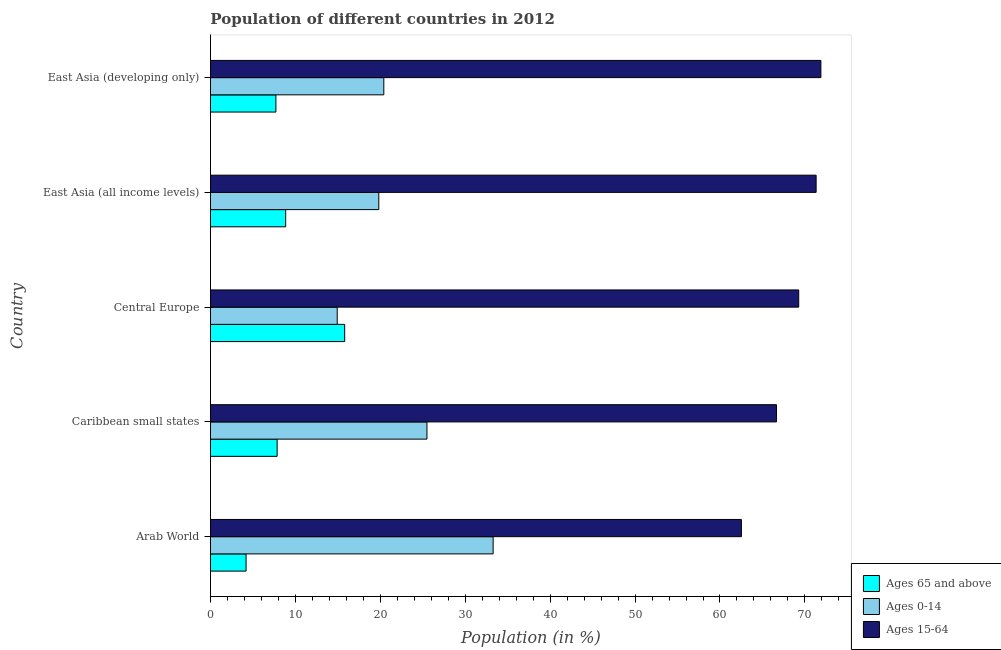How many different coloured bars are there?
Your response must be concise. 3. How many groups of bars are there?
Keep it short and to the point. 5. Are the number of bars per tick equal to the number of legend labels?
Provide a succinct answer. Yes. What is the label of the 2nd group of bars from the top?
Your answer should be compact. East Asia (all income levels). In how many cases, is the number of bars for a given country not equal to the number of legend labels?
Provide a succinct answer. 0. What is the percentage of population within the age-group 15-64 in Arab World?
Offer a terse response. 62.52. Across all countries, what is the maximum percentage of population within the age-group of 65 and above?
Your answer should be compact. 15.8. Across all countries, what is the minimum percentage of population within the age-group 15-64?
Your response must be concise. 62.52. In which country was the percentage of population within the age-group of 65 and above maximum?
Give a very brief answer. Central Europe. In which country was the percentage of population within the age-group 0-14 minimum?
Keep it short and to the point. Central Europe. What is the total percentage of population within the age-group 0-14 in the graph?
Your answer should be very brief. 113.94. What is the difference between the percentage of population within the age-group 0-14 in Arab World and that in East Asia (all income levels)?
Keep it short and to the point. 13.46. What is the difference between the percentage of population within the age-group of 65 and above in Caribbean small states and the percentage of population within the age-group 0-14 in East Asia (developing only)?
Make the answer very short. -12.56. What is the average percentage of population within the age-group of 65 and above per country?
Make the answer very short. 8.88. What is the difference between the percentage of population within the age-group 0-14 and percentage of population within the age-group 15-64 in Caribbean small states?
Your response must be concise. -41.16. In how many countries, is the percentage of population within the age-group 0-14 greater than 24 %?
Provide a succinct answer. 2. What is the ratio of the percentage of population within the age-group of 65 and above in Arab World to that in East Asia (developing only)?
Your answer should be very brief. 0.54. What is the difference between the highest and the second highest percentage of population within the age-group of 65 and above?
Provide a succinct answer. 6.95. What is the difference between the highest and the lowest percentage of population within the age-group 0-14?
Your answer should be compact. 18.36. Is the sum of the percentage of population within the age-group 0-14 in East Asia (all income levels) and East Asia (developing only) greater than the maximum percentage of population within the age-group 15-64 across all countries?
Provide a short and direct response. No. What does the 3rd bar from the top in Arab World represents?
Provide a succinct answer. Ages 65 and above. What does the 2nd bar from the bottom in Central Europe represents?
Provide a succinct answer. Ages 0-14. Is it the case that in every country, the sum of the percentage of population within the age-group of 65 and above and percentage of population within the age-group 0-14 is greater than the percentage of population within the age-group 15-64?
Offer a terse response. No. How many bars are there?
Make the answer very short. 15. Are all the bars in the graph horizontal?
Provide a short and direct response. Yes. Are the values on the major ticks of X-axis written in scientific E-notation?
Make the answer very short. No. Where does the legend appear in the graph?
Your answer should be very brief. Bottom right. What is the title of the graph?
Your answer should be compact. Population of different countries in 2012. What is the Population (in %) of Ages 65 and above in Arab World?
Provide a short and direct response. 4.19. What is the Population (in %) of Ages 0-14 in Arab World?
Your answer should be very brief. 33.29. What is the Population (in %) of Ages 15-64 in Arab World?
Make the answer very short. 62.52. What is the Population (in %) in Ages 65 and above in Caribbean small states?
Provide a succinct answer. 7.85. What is the Population (in %) in Ages 0-14 in Caribbean small states?
Give a very brief answer. 25.49. What is the Population (in %) of Ages 15-64 in Caribbean small states?
Make the answer very short. 66.66. What is the Population (in %) of Ages 65 and above in Central Europe?
Give a very brief answer. 15.8. What is the Population (in %) in Ages 0-14 in Central Europe?
Your answer should be very brief. 14.93. What is the Population (in %) of Ages 15-64 in Central Europe?
Keep it short and to the point. 69.27. What is the Population (in %) of Ages 65 and above in East Asia (all income levels)?
Provide a succinct answer. 8.86. What is the Population (in %) in Ages 0-14 in East Asia (all income levels)?
Ensure brevity in your answer.  19.82. What is the Population (in %) in Ages 15-64 in East Asia (all income levels)?
Make the answer very short. 71.32. What is the Population (in %) of Ages 65 and above in East Asia (developing only)?
Provide a succinct answer. 7.7. What is the Population (in %) in Ages 0-14 in East Asia (developing only)?
Your response must be concise. 20.41. What is the Population (in %) in Ages 15-64 in East Asia (developing only)?
Your response must be concise. 71.88. Across all countries, what is the maximum Population (in %) in Ages 65 and above?
Your answer should be very brief. 15.8. Across all countries, what is the maximum Population (in %) in Ages 0-14?
Ensure brevity in your answer.  33.29. Across all countries, what is the maximum Population (in %) in Ages 15-64?
Provide a short and direct response. 71.88. Across all countries, what is the minimum Population (in %) in Ages 65 and above?
Provide a succinct answer. 4.19. Across all countries, what is the minimum Population (in %) of Ages 0-14?
Offer a very short reply. 14.93. Across all countries, what is the minimum Population (in %) of Ages 15-64?
Ensure brevity in your answer.  62.52. What is the total Population (in %) of Ages 65 and above in the graph?
Offer a very short reply. 44.41. What is the total Population (in %) of Ages 0-14 in the graph?
Provide a short and direct response. 113.94. What is the total Population (in %) of Ages 15-64 in the graph?
Give a very brief answer. 341.65. What is the difference between the Population (in %) in Ages 65 and above in Arab World and that in Caribbean small states?
Offer a very short reply. -3.66. What is the difference between the Population (in %) in Ages 0-14 in Arab World and that in Caribbean small states?
Your response must be concise. 7.79. What is the difference between the Population (in %) in Ages 15-64 in Arab World and that in Caribbean small states?
Offer a terse response. -4.14. What is the difference between the Population (in %) in Ages 65 and above in Arab World and that in Central Europe?
Provide a short and direct response. -11.61. What is the difference between the Population (in %) in Ages 0-14 in Arab World and that in Central Europe?
Your answer should be compact. 18.36. What is the difference between the Population (in %) of Ages 15-64 in Arab World and that in Central Europe?
Give a very brief answer. -6.75. What is the difference between the Population (in %) in Ages 65 and above in Arab World and that in East Asia (all income levels)?
Provide a succinct answer. -4.66. What is the difference between the Population (in %) in Ages 0-14 in Arab World and that in East Asia (all income levels)?
Give a very brief answer. 13.46. What is the difference between the Population (in %) in Ages 15-64 in Arab World and that in East Asia (all income levels)?
Your response must be concise. -8.8. What is the difference between the Population (in %) in Ages 65 and above in Arab World and that in East Asia (developing only)?
Give a very brief answer. -3.51. What is the difference between the Population (in %) in Ages 0-14 in Arab World and that in East Asia (developing only)?
Your answer should be compact. 12.87. What is the difference between the Population (in %) of Ages 15-64 in Arab World and that in East Asia (developing only)?
Provide a succinct answer. -9.36. What is the difference between the Population (in %) in Ages 65 and above in Caribbean small states and that in Central Europe?
Your answer should be compact. -7.95. What is the difference between the Population (in %) of Ages 0-14 in Caribbean small states and that in Central Europe?
Give a very brief answer. 10.57. What is the difference between the Population (in %) in Ages 15-64 in Caribbean small states and that in Central Europe?
Ensure brevity in your answer.  -2.61. What is the difference between the Population (in %) in Ages 65 and above in Caribbean small states and that in East Asia (all income levels)?
Keep it short and to the point. -1.01. What is the difference between the Population (in %) of Ages 0-14 in Caribbean small states and that in East Asia (all income levels)?
Your response must be concise. 5.67. What is the difference between the Population (in %) of Ages 15-64 in Caribbean small states and that in East Asia (all income levels)?
Offer a very short reply. -4.67. What is the difference between the Population (in %) of Ages 65 and above in Caribbean small states and that in East Asia (developing only)?
Offer a very short reply. 0.15. What is the difference between the Population (in %) in Ages 0-14 in Caribbean small states and that in East Asia (developing only)?
Give a very brief answer. 5.08. What is the difference between the Population (in %) of Ages 15-64 in Caribbean small states and that in East Asia (developing only)?
Offer a terse response. -5.23. What is the difference between the Population (in %) in Ages 65 and above in Central Europe and that in East Asia (all income levels)?
Your answer should be very brief. 6.95. What is the difference between the Population (in %) of Ages 0-14 in Central Europe and that in East Asia (all income levels)?
Your answer should be very brief. -4.9. What is the difference between the Population (in %) in Ages 15-64 in Central Europe and that in East Asia (all income levels)?
Provide a succinct answer. -2.05. What is the difference between the Population (in %) in Ages 65 and above in Central Europe and that in East Asia (developing only)?
Provide a succinct answer. 8.1. What is the difference between the Population (in %) in Ages 0-14 in Central Europe and that in East Asia (developing only)?
Offer a very short reply. -5.49. What is the difference between the Population (in %) of Ages 15-64 in Central Europe and that in East Asia (developing only)?
Offer a terse response. -2.61. What is the difference between the Population (in %) of Ages 65 and above in East Asia (all income levels) and that in East Asia (developing only)?
Provide a succinct answer. 1.15. What is the difference between the Population (in %) of Ages 0-14 in East Asia (all income levels) and that in East Asia (developing only)?
Give a very brief answer. -0.59. What is the difference between the Population (in %) of Ages 15-64 in East Asia (all income levels) and that in East Asia (developing only)?
Give a very brief answer. -0.56. What is the difference between the Population (in %) of Ages 65 and above in Arab World and the Population (in %) of Ages 0-14 in Caribbean small states?
Offer a very short reply. -21.3. What is the difference between the Population (in %) of Ages 65 and above in Arab World and the Population (in %) of Ages 15-64 in Caribbean small states?
Ensure brevity in your answer.  -62.46. What is the difference between the Population (in %) in Ages 0-14 in Arab World and the Population (in %) in Ages 15-64 in Caribbean small states?
Provide a short and direct response. -33.37. What is the difference between the Population (in %) in Ages 65 and above in Arab World and the Population (in %) in Ages 0-14 in Central Europe?
Give a very brief answer. -10.73. What is the difference between the Population (in %) of Ages 65 and above in Arab World and the Population (in %) of Ages 15-64 in Central Europe?
Offer a very short reply. -65.08. What is the difference between the Population (in %) of Ages 0-14 in Arab World and the Population (in %) of Ages 15-64 in Central Europe?
Give a very brief answer. -35.98. What is the difference between the Population (in %) in Ages 65 and above in Arab World and the Population (in %) in Ages 0-14 in East Asia (all income levels)?
Provide a short and direct response. -15.63. What is the difference between the Population (in %) of Ages 65 and above in Arab World and the Population (in %) of Ages 15-64 in East Asia (all income levels)?
Offer a terse response. -67.13. What is the difference between the Population (in %) in Ages 0-14 in Arab World and the Population (in %) in Ages 15-64 in East Asia (all income levels)?
Provide a succinct answer. -38.04. What is the difference between the Population (in %) in Ages 65 and above in Arab World and the Population (in %) in Ages 0-14 in East Asia (developing only)?
Your answer should be very brief. -16.22. What is the difference between the Population (in %) in Ages 65 and above in Arab World and the Population (in %) in Ages 15-64 in East Asia (developing only)?
Your answer should be very brief. -67.69. What is the difference between the Population (in %) in Ages 0-14 in Arab World and the Population (in %) in Ages 15-64 in East Asia (developing only)?
Give a very brief answer. -38.6. What is the difference between the Population (in %) of Ages 65 and above in Caribbean small states and the Population (in %) of Ages 0-14 in Central Europe?
Offer a very short reply. -7.08. What is the difference between the Population (in %) in Ages 65 and above in Caribbean small states and the Population (in %) in Ages 15-64 in Central Europe?
Provide a short and direct response. -61.42. What is the difference between the Population (in %) of Ages 0-14 in Caribbean small states and the Population (in %) of Ages 15-64 in Central Europe?
Provide a short and direct response. -43.78. What is the difference between the Population (in %) of Ages 65 and above in Caribbean small states and the Population (in %) of Ages 0-14 in East Asia (all income levels)?
Your answer should be compact. -11.97. What is the difference between the Population (in %) in Ages 65 and above in Caribbean small states and the Population (in %) in Ages 15-64 in East Asia (all income levels)?
Provide a succinct answer. -63.47. What is the difference between the Population (in %) in Ages 0-14 in Caribbean small states and the Population (in %) in Ages 15-64 in East Asia (all income levels)?
Offer a terse response. -45.83. What is the difference between the Population (in %) of Ages 65 and above in Caribbean small states and the Population (in %) of Ages 0-14 in East Asia (developing only)?
Your answer should be compact. -12.56. What is the difference between the Population (in %) in Ages 65 and above in Caribbean small states and the Population (in %) in Ages 15-64 in East Asia (developing only)?
Your answer should be very brief. -64.03. What is the difference between the Population (in %) of Ages 0-14 in Caribbean small states and the Population (in %) of Ages 15-64 in East Asia (developing only)?
Make the answer very short. -46.39. What is the difference between the Population (in %) in Ages 65 and above in Central Europe and the Population (in %) in Ages 0-14 in East Asia (all income levels)?
Make the answer very short. -4.02. What is the difference between the Population (in %) in Ages 65 and above in Central Europe and the Population (in %) in Ages 15-64 in East Asia (all income levels)?
Keep it short and to the point. -55.52. What is the difference between the Population (in %) of Ages 0-14 in Central Europe and the Population (in %) of Ages 15-64 in East Asia (all income levels)?
Your answer should be very brief. -56.4. What is the difference between the Population (in %) of Ages 65 and above in Central Europe and the Population (in %) of Ages 0-14 in East Asia (developing only)?
Offer a terse response. -4.61. What is the difference between the Population (in %) of Ages 65 and above in Central Europe and the Population (in %) of Ages 15-64 in East Asia (developing only)?
Offer a very short reply. -56.08. What is the difference between the Population (in %) in Ages 0-14 in Central Europe and the Population (in %) in Ages 15-64 in East Asia (developing only)?
Offer a very short reply. -56.96. What is the difference between the Population (in %) in Ages 65 and above in East Asia (all income levels) and the Population (in %) in Ages 0-14 in East Asia (developing only)?
Your response must be concise. -11.56. What is the difference between the Population (in %) in Ages 65 and above in East Asia (all income levels) and the Population (in %) in Ages 15-64 in East Asia (developing only)?
Keep it short and to the point. -63.03. What is the difference between the Population (in %) of Ages 0-14 in East Asia (all income levels) and the Population (in %) of Ages 15-64 in East Asia (developing only)?
Offer a terse response. -52.06. What is the average Population (in %) of Ages 65 and above per country?
Your answer should be very brief. 8.88. What is the average Population (in %) of Ages 0-14 per country?
Keep it short and to the point. 22.79. What is the average Population (in %) of Ages 15-64 per country?
Your answer should be very brief. 68.33. What is the difference between the Population (in %) of Ages 65 and above and Population (in %) of Ages 0-14 in Arab World?
Keep it short and to the point. -29.09. What is the difference between the Population (in %) of Ages 65 and above and Population (in %) of Ages 15-64 in Arab World?
Make the answer very short. -58.33. What is the difference between the Population (in %) of Ages 0-14 and Population (in %) of Ages 15-64 in Arab World?
Your answer should be very brief. -29.23. What is the difference between the Population (in %) of Ages 65 and above and Population (in %) of Ages 0-14 in Caribbean small states?
Your response must be concise. -17.64. What is the difference between the Population (in %) of Ages 65 and above and Population (in %) of Ages 15-64 in Caribbean small states?
Your answer should be very brief. -58.81. What is the difference between the Population (in %) in Ages 0-14 and Population (in %) in Ages 15-64 in Caribbean small states?
Give a very brief answer. -41.16. What is the difference between the Population (in %) of Ages 65 and above and Population (in %) of Ages 0-14 in Central Europe?
Give a very brief answer. 0.88. What is the difference between the Population (in %) in Ages 65 and above and Population (in %) in Ages 15-64 in Central Europe?
Make the answer very short. -53.47. What is the difference between the Population (in %) of Ages 0-14 and Population (in %) of Ages 15-64 in Central Europe?
Offer a very short reply. -54.34. What is the difference between the Population (in %) of Ages 65 and above and Population (in %) of Ages 0-14 in East Asia (all income levels)?
Ensure brevity in your answer.  -10.97. What is the difference between the Population (in %) in Ages 65 and above and Population (in %) in Ages 15-64 in East Asia (all income levels)?
Make the answer very short. -62.47. What is the difference between the Population (in %) in Ages 0-14 and Population (in %) in Ages 15-64 in East Asia (all income levels)?
Make the answer very short. -51.5. What is the difference between the Population (in %) of Ages 65 and above and Population (in %) of Ages 0-14 in East Asia (developing only)?
Offer a very short reply. -12.71. What is the difference between the Population (in %) in Ages 65 and above and Population (in %) in Ages 15-64 in East Asia (developing only)?
Ensure brevity in your answer.  -64.18. What is the difference between the Population (in %) of Ages 0-14 and Population (in %) of Ages 15-64 in East Asia (developing only)?
Offer a terse response. -51.47. What is the ratio of the Population (in %) of Ages 65 and above in Arab World to that in Caribbean small states?
Provide a succinct answer. 0.53. What is the ratio of the Population (in %) in Ages 0-14 in Arab World to that in Caribbean small states?
Ensure brevity in your answer.  1.31. What is the ratio of the Population (in %) in Ages 15-64 in Arab World to that in Caribbean small states?
Make the answer very short. 0.94. What is the ratio of the Population (in %) of Ages 65 and above in Arab World to that in Central Europe?
Give a very brief answer. 0.27. What is the ratio of the Population (in %) of Ages 0-14 in Arab World to that in Central Europe?
Provide a succinct answer. 2.23. What is the ratio of the Population (in %) in Ages 15-64 in Arab World to that in Central Europe?
Offer a very short reply. 0.9. What is the ratio of the Population (in %) in Ages 65 and above in Arab World to that in East Asia (all income levels)?
Provide a succinct answer. 0.47. What is the ratio of the Population (in %) of Ages 0-14 in Arab World to that in East Asia (all income levels)?
Ensure brevity in your answer.  1.68. What is the ratio of the Population (in %) in Ages 15-64 in Arab World to that in East Asia (all income levels)?
Provide a short and direct response. 0.88. What is the ratio of the Population (in %) of Ages 65 and above in Arab World to that in East Asia (developing only)?
Your answer should be very brief. 0.54. What is the ratio of the Population (in %) of Ages 0-14 in Arab World to that in East Asia (developing only)?
Your response must be concise. 1.63. What is the ratio of the Population (in %) of Ages 15-64 in Arab World to that in East Asia (developing only)?
Offer a very short reply. 0.87. What is the ratio of the Population (in %) in Ages 65 and above in Caribbean small states to that in Central Europe?
Your answer should be very brief. 0.5. What is the ratio of the Population (in %) of Ages 0-14 in Caribbean small states to that in Central Europe?
Your answer should be compact. 1.71. What is the ratio of the Population (in %) of Ages 15-64 in Caribbean small states to that in Central Europe?
Offer a terse response. 0.96. What is the ratio of the Population (in %) of Ages 65 and above in Caribbean small states to that in East Asia (all income levels)?
Offer a terse response. 0.89. What is the ratio of the Population (in %) in Ages 0-14 in Caribbean small states to that in East Asia (all income levels)?
Your response must be concise. 1.29. What is the ratio of the Population (in %) of Ages 15-64 in Caribbean small states to that in East Asia (all income levels)?
Make the answer very short. 0.93. What is the ratio of the Population (in %) in Ages 65 and above in Caribbean small states to that in East Asia (developing only)?
Your answer should be compact. 1.02. What is the ratio of the Population (in %) in Ages 0-14 in Caribbean small states to that in East Asia (developing only)?
Provide a short and direct response. 1.25. What is the ratio of the Population (in %) in Ages 15-64 in Caribbean small states to that in East Asia (developing only)?
Make the answer very short. 0.93. What is the ratio of the Population (in %) in Ages 65 and above in Central Europe to that in East Asia (all income levels)?
Ensure brevity in your answer.  1.78. What is the ratio of the Population (in %) in Ages 0-14 in Central Europe to that in East Asia (all income levels)?
Ensure brevity in your answer.  0.75. What is the ratio of the Population (in %) of Ages 15-64 in Central Europe to that in East Asia (all income levels)?
Offer a terse response. 0.97. What is the ratio of the Population (in %) of Ages 65 and above in Central Europe to that in East Asia (developing only)?
Your response must be concise. 2.05. What is the ratio of the Population (in %) of Ages 0-14 in Central Europe to that in East Asia (developing only)?
Ensure brevity in your answer.  0.73. What is the ratio of the Population (in %) in Ages 15-64 in Central Europe to that in East Asia (developing only)?
Your answer should be very brief. 0.96. What is the ratio of the Population (in %) of Ages 65 and above in East Asia (all income levels) to that in East Asia (developing only)?
Ensure brevity in your answer.  1.15. What is the ratio of the Population (in %) of Ages 0-14 in East Asia (all income levels) to that in East Asia (developing only)?
Keep it short and to the point. 0.97. What is the difference between the highest and the second highest Population (in %) of Ages 65 and above?
Provide a succinct answer. 6.95. What is the difference between the highest and the second highest Population (in %) in Ages 0-14?
Your response must be concise. 7.79. What is the difference between the highest and the second highest Population (in %) in Ages 15-64?
Ensure brevity in your answer.  0.56. What is the difference between the highest and the lowest Population (in %) in Ages 65 and above?
Your answer should be very brief. 11.61. What is the difference between the highest and the lowest Population (in %) in Ages 0-14?
Provide a succinct answer. 18.36. What is the difference between the highest and the lowest Population (in %) in Ages 15-64?
Give a very brief answer. 9.36. 